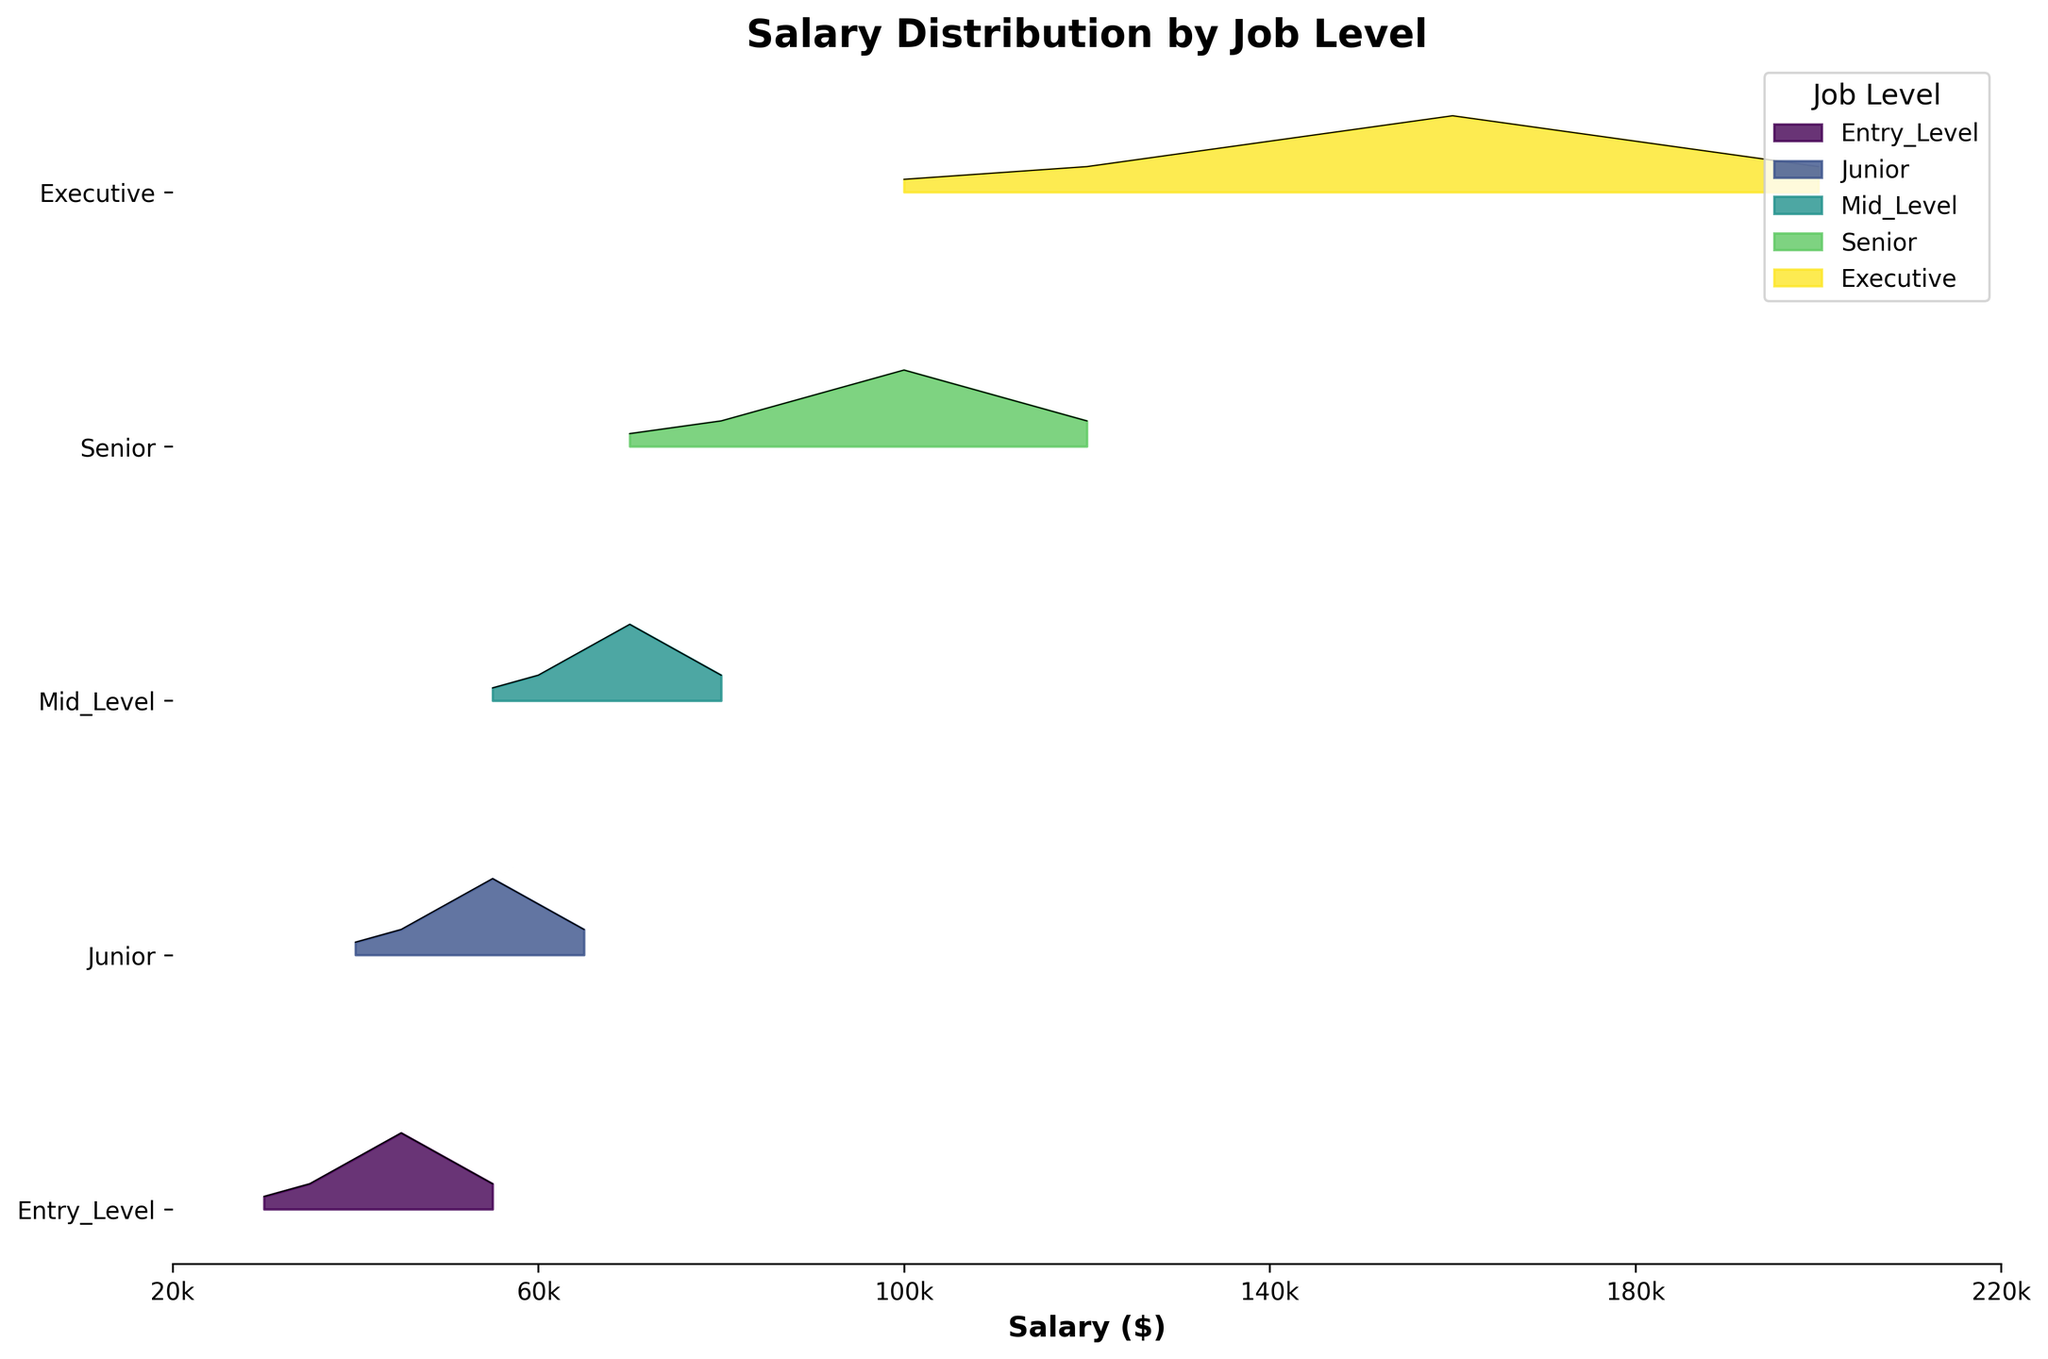What is the title of the plot? The title can be found at the top of the plot, usually in bold. It provides a brief description of what the plot is about.
Answer: Salary Distribution by Job Level Which job level has the highest maximum salary density? Look at the peaks of each density curve in the ridgeline plot. Compare the maximum values of the densities across different job levels.
Answer: Executive What is the approximate salary range for Junior level employees? Identify the range on the x-axis where the density curve for Junior level starts and ends.
Answer: $40,000 to $65,000 Which job level has the widest salary range? Observe the horizontal span of each job level's distribution curve from its start to end point on the x-axis.
Answer: Executive At what salary do Mid-Level and Senior level employees' distributions overlap the most? Identify the area on the x-axis where the density curves for Mid-Level and Senior level employees intersect or are closest to each other.
Answer: Around $70,000 Are the salary ranges for Entry Level and Junior employees completely separate? Compare the horizontal ranges (x-axis) of the density curves for Entry Level and Junior employees to see if they intersect or overlap.
Answer: Yes, they overlap between $40,000 and $55,000 By how much do the maximum salaries for Mid-Level and Senior level employees differ? Determine the highest salary for both Mid-Level and Senior level employees from the plot, then calculate their difference.
Answer: $40,000 Which job levels have overlapping salary ranges between $100,000 and $120,000? Look at the density curves on the x-axis segment between $100,000 and $120,000 to see which job levels have densities within this range.
Answer: Senior and Executive What salary represents the peak density for Entry Level employees? Identify the salary value on the x-axis where the Entry Level density curve reaches its maximum height.
Answer: $45,000 Do any job levels have a salary range that extends to $200,000? Check which job levels' density curves reach up to or include the $200,000 mark on the x-axis.
Answer: Executive 